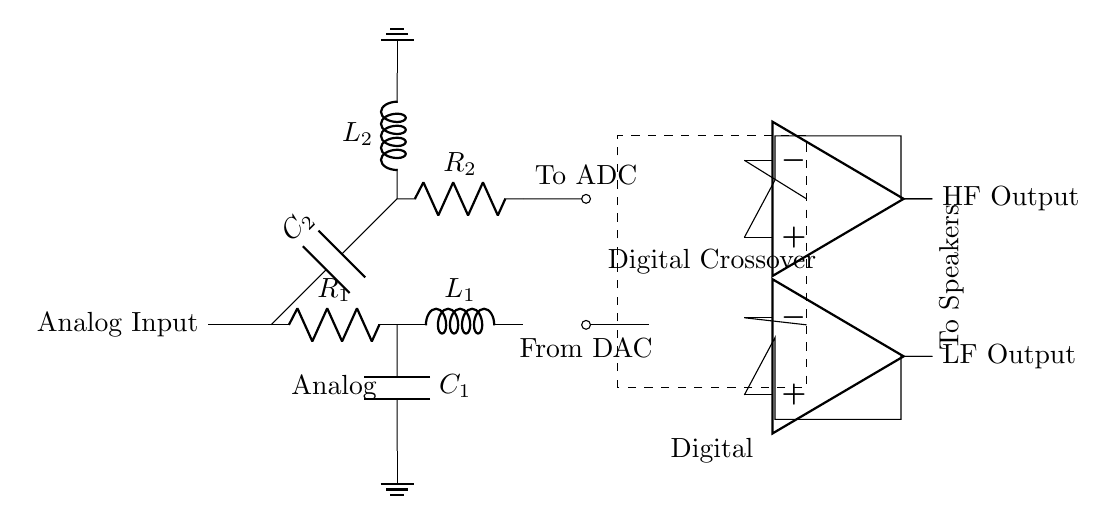What is the type of the input in this circuit? The input is labeled as "Analog Input," indicating that it is an analog signal that will be processed by the circuit.
Answer: Analog Input What are the components used for the low-pass filter? The low-pass filter consists of a resistor labeled R1, an inductor labeled L1, and a capacitor labeled C1, which are connected in a certain arrangement to allow low frequencies to pass while attenuating higher frequencies.
Answer: R1, L1, C1 What is the role of the digital crossover in this circuit? The digital crossover processes the signal digitally after it has been converted from analog to digital by the ADC, splitting the audio into high-frequency and low-frequency components that can be amplified separately.
Answer: Signal processing How many output amplifiers are present in the circuit? There are two output amplifiers, one for high-frequency output and one for low-frequency output, as identified by their placement and the labels HF Output and LF Output.
Answer: Two What do the letters ADC and DAC stand for in this diagram? ADC stands for Analog to Digital Converter, which converts analog signals to digital form; DAC stands for Digital to Analog Converter, which converts digital signals back into analog.
Answer: Analog to Digital Converter and Digital to Analog Converter What is the function of the capacitor C2 in the high-pass filter? Capacitor C2 blocks low-frequency signals while allowing higher frequencies to pass through, contributing to the overall function of the high-pass filter in the circuit.
Answer: Blocks low frequencies What is indicated by the dashed rectangle in the circuit? The dashed rectangle represents the Digital Crossover section of the circuit, indicating a digital processing area where the audio signal is divided into different frequency bands.
Answer: Digital Crossover 